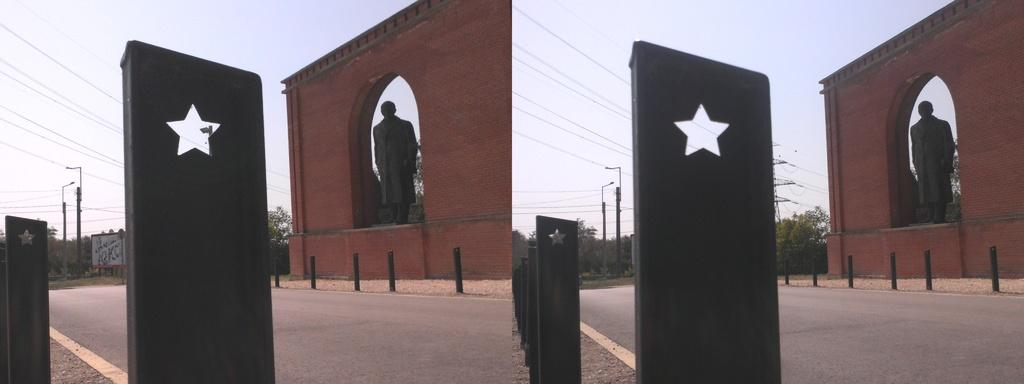What type of artwork is the image? The image is a collage. What is one of the main subjects in the collage? There is a statue in the collage. What type of natural elements can be seen in the collage? There are trees in the collage. What man-made elements can be seen in the collage? There are wires in the collage. What part of the natural environment is visible in the collage? The sky is visible in the collage. What type of food is being prepared in the collage? There is no food or preparation of food depicted in the collage. 